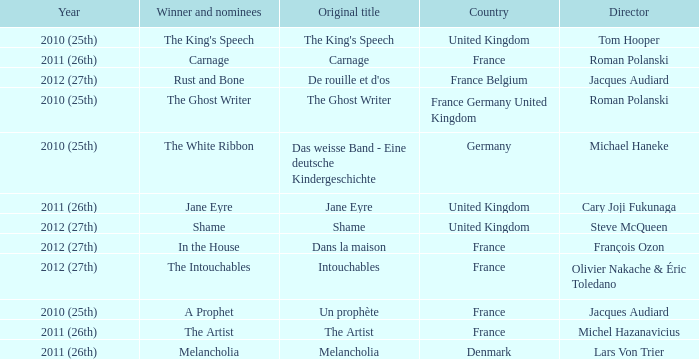What was the original title for the king's speech? The King's Speech. 